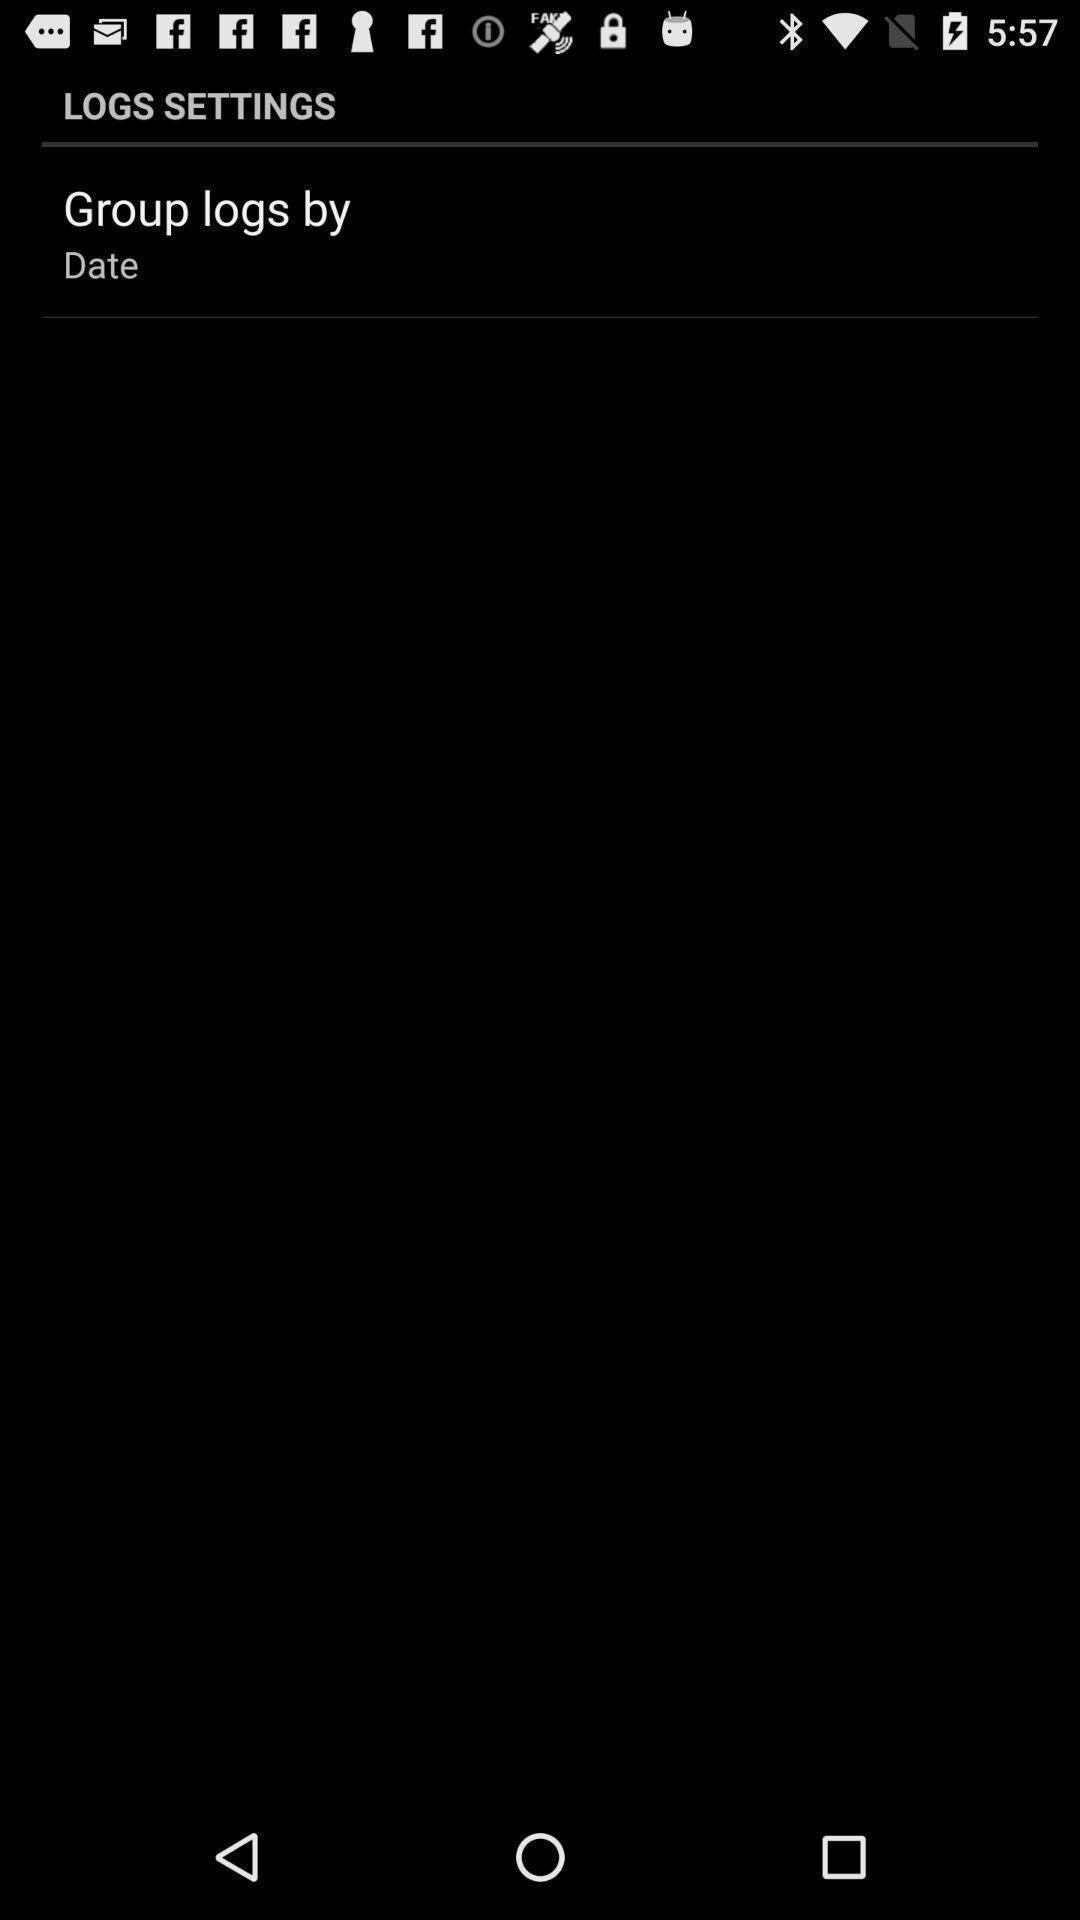Summarize the main components in this picture. Page displaying a setting in application. 